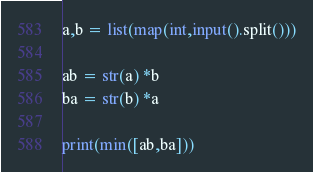Convert code to text. <code><loc_0><loc_0><loc_500><loc_500><_Python_>a,b = list(map(int,input().split()))

ab = str(a) *b
ba = str(b) *a

print(min([ab,ba]))
</code> 